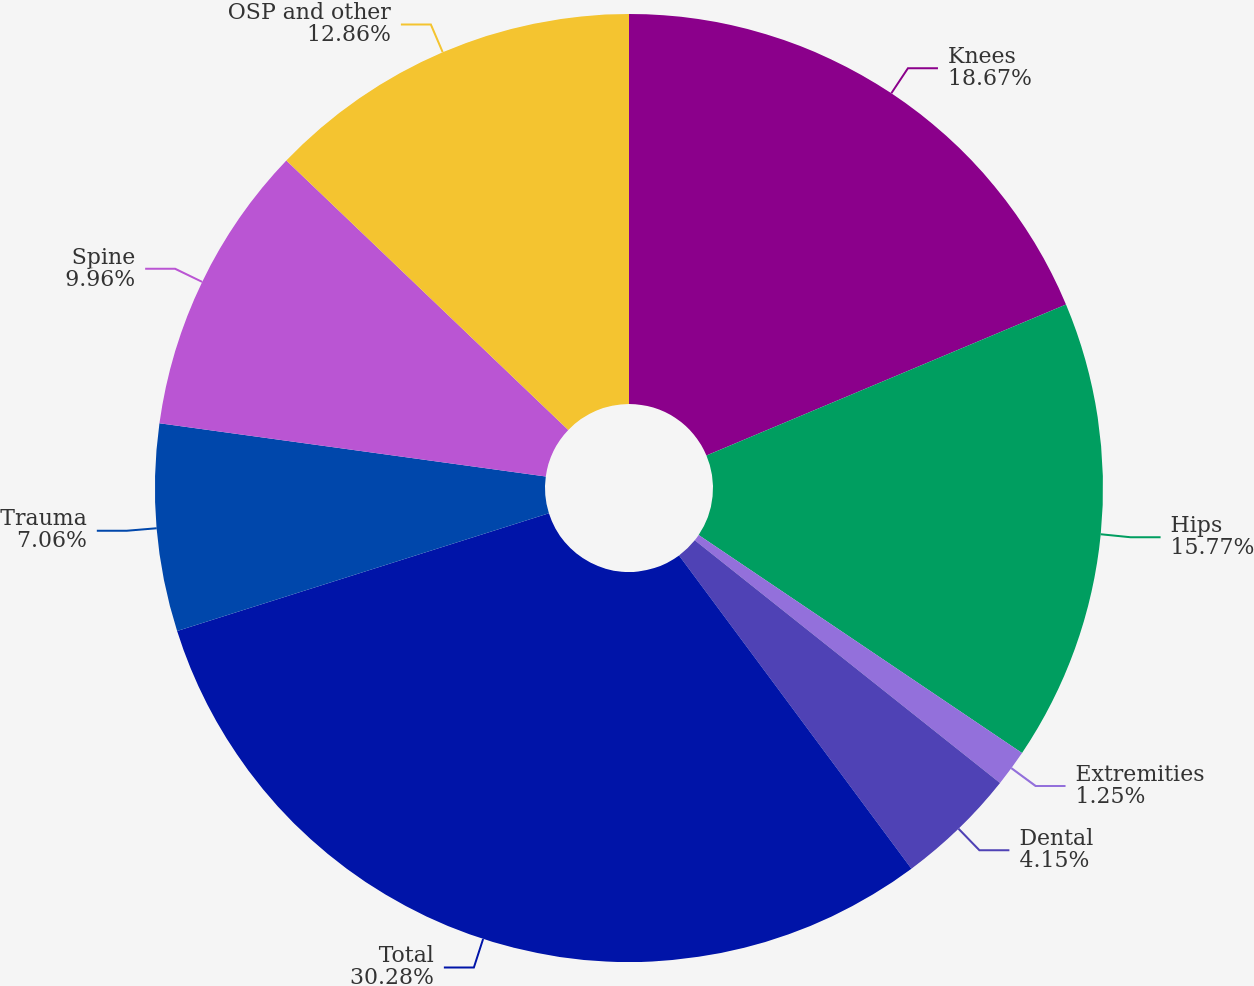Convert chart to OTSL. <chart><loc_0><loc_0><loc_500><loc_500><pie_chart><fcel>Knees<fcel>Hips<fcel>Extremities<fcel>Dental<fcel>Total<fcel>Trauma<fcel>Spine<fcel>OSP and other<nl><fcel>18.67%<fcel>15.77%<fcel>1.25%<fcel>4.15%<fcel>30.28%<fcel>7.06%<fcel>9.96%<fcel>12.86%<nl></chart> 